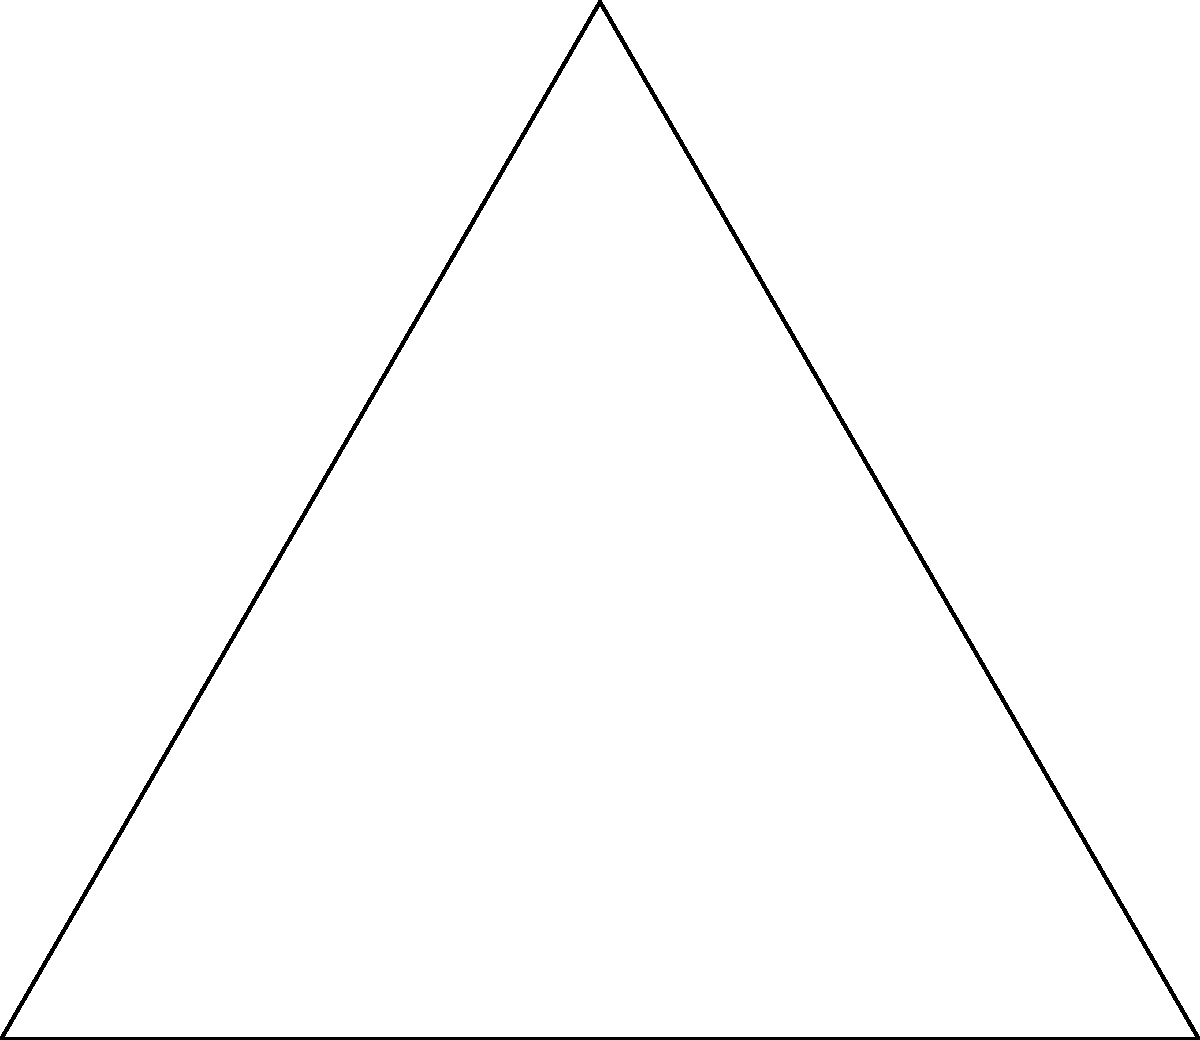Compare the internal angles of the Star of David with the right angle in the Christian cross. How does this difference in angles reflect the symbolic and theological significance of these religious symbols? To understand the significance of the angles in these religious symbols, let's analyze them step-by-step:

1. Star of David:
   - The Star of David is composed of two equilateral triangles.
   - Each internal angle of an equilateral triangle is $60^\circ$.
   - The star has six points, each with an internal angle of $60^\circ$.

2. Christian Cross:
   - The Christian cross is typically depicted with a vertical beam intersected by a horizontal beam.
   - The intersection forms four right angles, each measuring $90^\circ$.

3. Symbolic significance:
   - Star of David ($60^\circ$ angles):
     a) Represents balance and harmony in Judaism.
     b) Six points symbolize God's rule over the universe in six directions.
     c) The equilateral triangles represent the connection between God and humanity.

   - Christian Cross ($90^\circ$ angles):
     a) Represents the intersection of divine (vertical) and earthly (horizontal) realms.
     b) Right angles symbolize the perfection and completeness of Christ's sacrifice.
     c) The four right angles can represent the four corners of the earth, signifying universal salvation.

4. Theological implications:
   - The $60^\circ$ angles in the Star of David reflect the idea of continuous movement and cyclical nature in Jewish thought.
   - The $90^\circ$ angles in the Christian cross emphasize stability, foundation, and the finality of Christ's redemptive work.

5. Cultural context:
   - In the US education system, these symbols are often studied in comparative religion courses, emphasizing interfaith understanding and respect for diverse belief systems.

The difference in angles between these symbols reflects their distinct theological concepts and the unique spiritual journeys they represent within their respective faith traditions.
Answer: The $60^\circ$ angles in the Star of David represent balance and cyclical movement in Judaism, while the $90^\circ$ angles in the Christian cross symbolize stability and the intersection of divine and earthly realms in Christianity. 